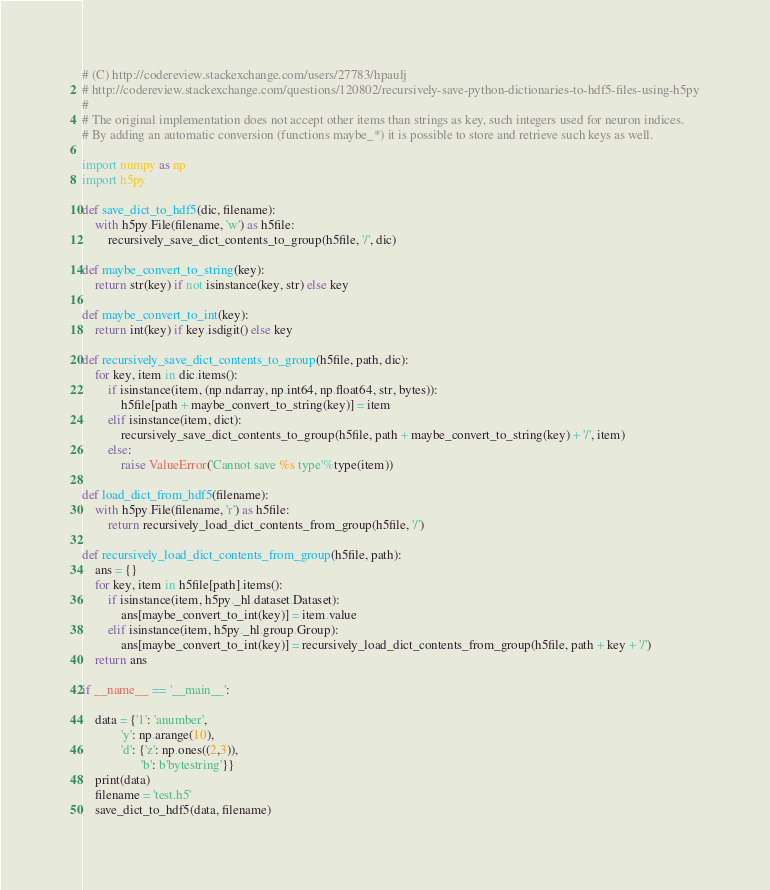<code> <loc_0><loc_0><loc_500><loc_500><_Python_># (C) http://codereview.stackexchange.com/users/27783/hpaulj
# http://codereview.stackexchange.com/questions/120802/recursively-save-python-dictionaries-to-hdf5-files-using-h5py
#
# The original implementation does not accept other items than strings as key, such integers used for neuron indices.
# By adding an automatic conversion (functions maybe_*) it is possible to store and retrieve such keys as well.

import numpy as np
import h5py

def save_dict_to_hdf5(dic, filename):
    with h5py.File(filename, 'w') as h5file:
        recursively_save_dict_contents_to_group(h5file, '/', dic)

def maybe_convert_to_string(key):
    return str(key) if not isinstance(key, str) else key

def maybe_convert_to_int(key):
    return int(key) if key.isdigit() else key

def recursively_save_dict_contents_to_group(h5file, path, dic):
    for key, item in dic.items():
        if isinstance(item, (np.ndarray, np.int64, np.float64, str, bytes)):
            h5file[path + maybe_convert_to_string(key)] = item
        elif isinstance(item, dict):
            recursively_save_dict_contents_to_group(h5file, path + maybe_convert_to_string(key) + '/', item)
        else:
            raise ValueError('Cannot save %s type'%type(item))

def load_dict_from_hdf5(filename):
    with h5py.File(filename, 'r') as h5file:
        return recursively_load_dict_contents_from_group(h5file, '/')

def recursively_load_dict_contents_from_group(h5file, path):
    ans = {}
    for key, item in h5file[path].items():
        if isinstance(item, h5py._hl.dataset.Dataset):
            ans[maybe_convert_to_int(key)] = item.value
        elif isinstance(item, h5py._hl.group.Group):
            ans[maybe_convert_to_int(key)] = recursively_load_dict_contents_from_group(h5file, path + key + '/')
    return ans

if __name__ == '__main__':

    data = {'1': 'anumber',
            'y': np.arange(10),
            'd': {'z': np.ones((2,3)),
                  'b': b'bytestring'}}
    print(data)
    filename = 'test.h5'
    save_dict_to_hdf5(data, filename)</code> 